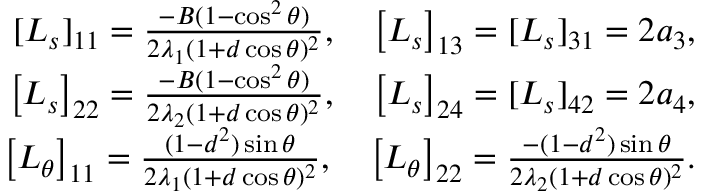<formula> <loc_0><loc_0><loc_500><loc_500>\begin{array} { r } { [ L _ { s } ] _ { 1 1 } = \frac { - B ( 1 - \cos ^ { 2 } \theta ) } { 2 \lambda _ { 1 } ( 1 + d \cos \theta ) ^ { 2 } } , \quad \left [ L _ { s } \right ] _ { 1 3 } = [ L _ { s } ] _ { 3 1 } = 2 a _ { 3 } , } \\ { \left [ L _ { s } \right ] _ { 2 2 } = \frac { - B ( 1 - \cos ^ { 2 } \theta ) } { 2 \lambda _ { 2 } ( 1 + d \cos \theta ) ^ { 2 } } , \quad \left [ L _ { s } \right ] _ { 2 4 } = [ L _ { s } ] _ { 4 2 } = 2 a _ { 4 } , } \\ { \left [ L _ { \theta } \right ] _ { 1 1 } = \frac { ( 1 - d ^ { 2 } ) \sin \theta } { 2 \lambda _ { 1 } ( 1 + d \cos \theta ) ^ { 2 } } , \quad \left [ L _ { \theta } \right ] _ { 2 2 } = \frac { - ( 1 - d ^ { 2 } ) \sin \theta } { 2 \lambda _ { 2 } ( 1 + d \cos \theta ) ^ { 2 } } . } \end{array}</formula> 